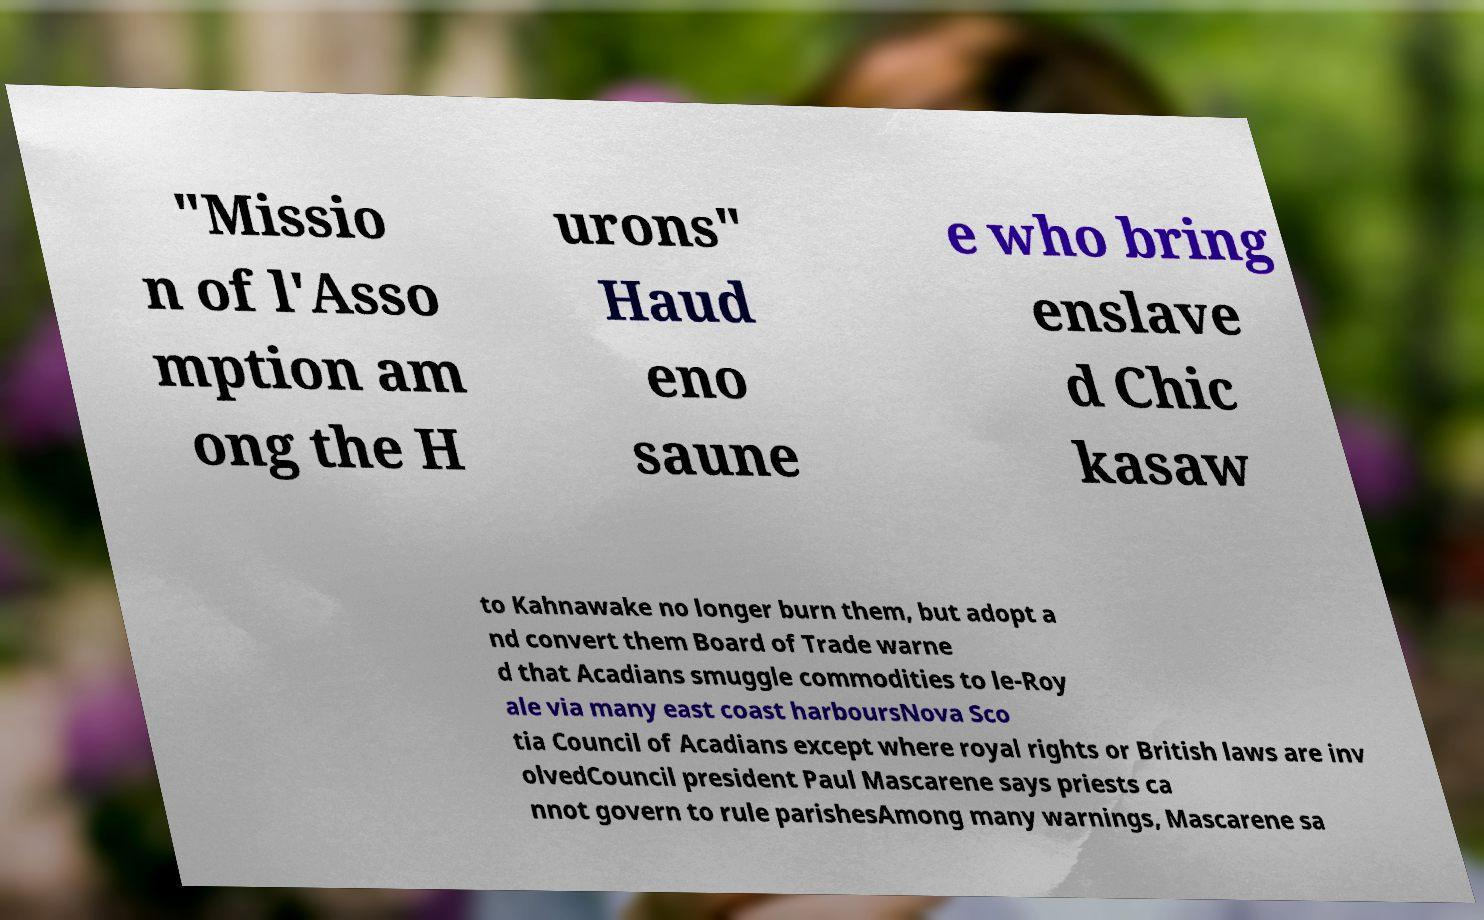Please identify and transcribe the text found in this image. "Missio n of l'Asso mption am ong the H urons" Haud eno saune e who bring enslave d Chic kasaw to Kahnawake no longer burn them, but adopt a nd convert them Board of Trade warne d that Acadians smuggle commodities to le-Roy ale via many east coast harboursNova Sco tia Council of Acadians except where royal rights or British laws are inv olvedCouncil president Paul Mascarene says priests ca nnot govern to rule parishesAmong many warnings, Mascarene sa 